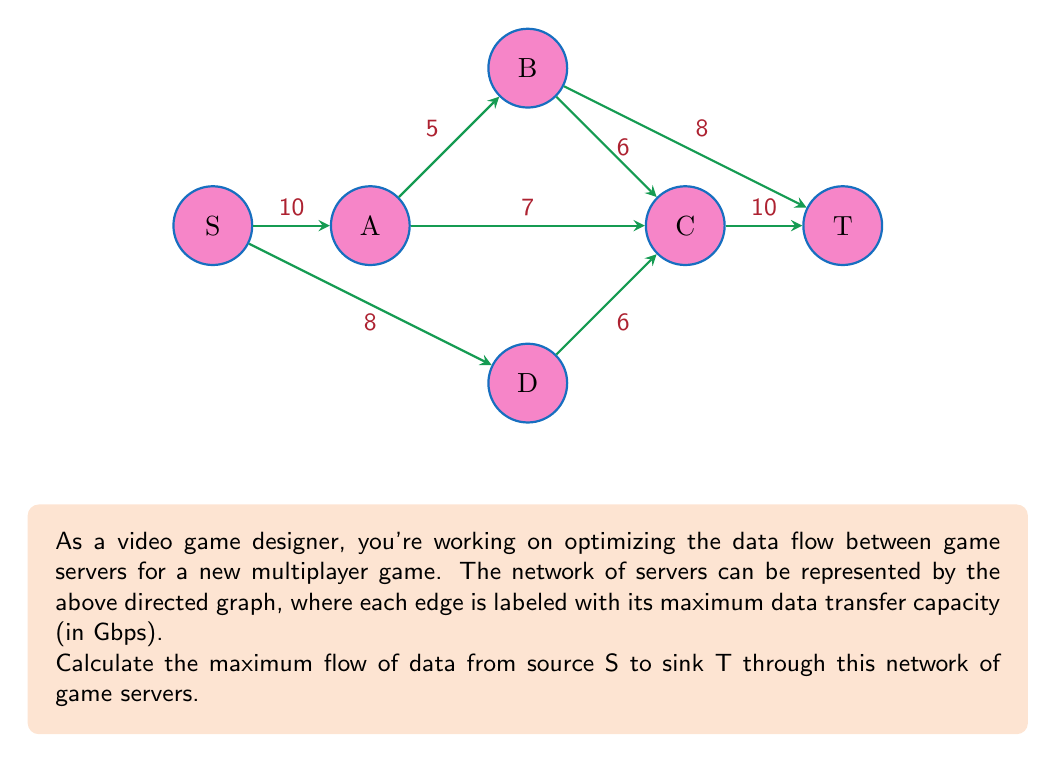Give your solution to this math problem. To solve this maximum flow problem, we can use the Ford-Fulkerson algorithm. Here's a step-by-step explanation:

1) Initialize the flow on all edges to 0.

2) Find an augmenting path from S to T. We can use DFS or BFS for this. Let's go through the paths:

   Path 1: S -> A -> B -> T (min capacity = 5)
   Augment flow: 5
   Residual graph:
   S -> A: 5/10
   A -> B: 5/5
   B -> T: 5/8

   Path 2: S -> A -> C -> T (min capacity = 7)
   Augment flow: 7
   Residual graph:
   S -> A: 10/10
   A -> C: 7/7
   C -> T: 7/10

   Path 3: S -> D -> C -> T (min capacity = 3)
   Augment flow: 3
   Residual graph:
   S -> D: 3/8
   D -> C: 3/6
   C -> T: 10/10

   Path 4: S -> D -> C -> B -> T (min capacity = 3)
   Augment flow: 3
   Final residual graph:
   S -> D: 6/8
   D -> C: 6/6
   C -> B: 3/6
   B -> T: 8/8

3) No more augmenting paths exist, so we've reached the maximum flow.

4) Sum up the flows on edges leaving the source S:
   Flow(S -> A) + Flow(S -> D) = 10 + 6 = 16

Therefore, the maximum flow from S to T is 16 Gbps.
Answer: 16 Gbps 